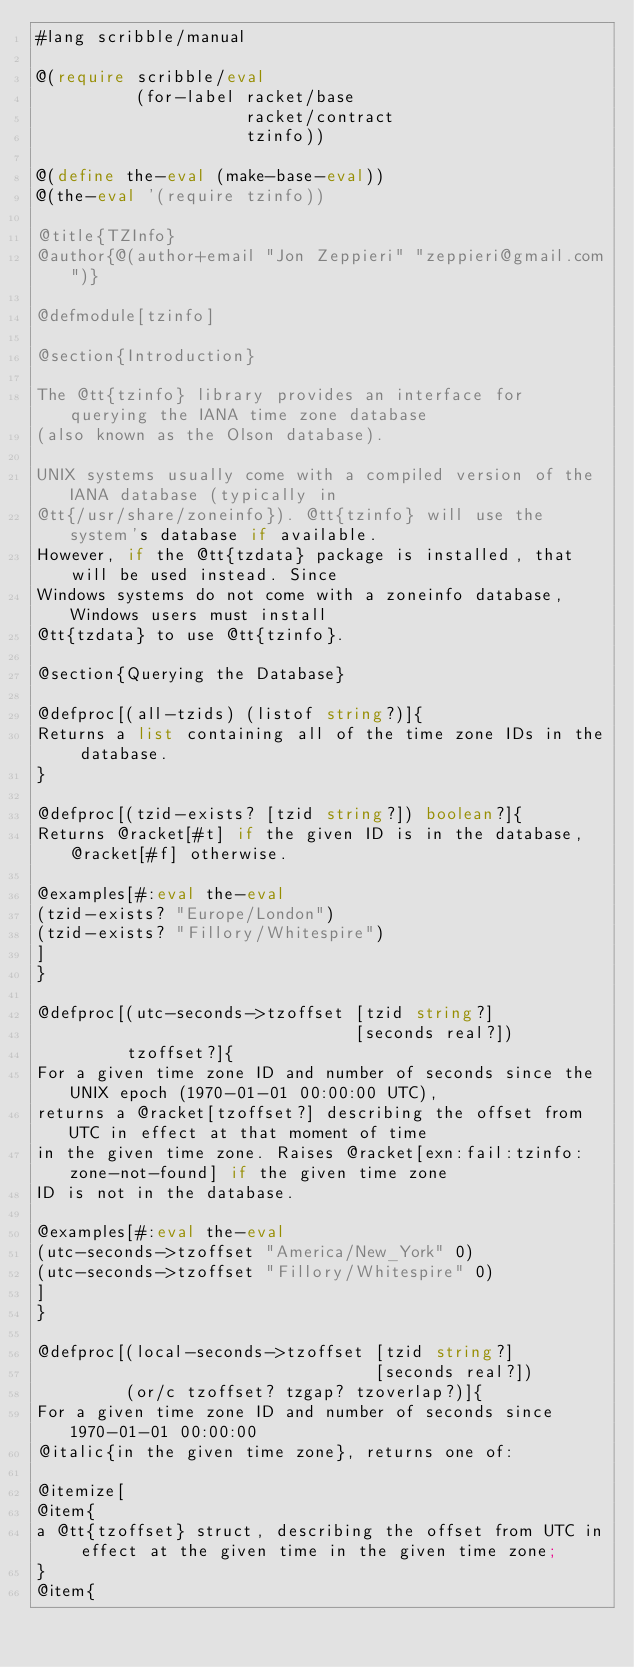<code> <loc_0><loc_0><loc_500><loc_500><_Racket_>#lang scribble/manual

@(require scribble/eval
          (for-label racket/base
                     racket/contract
                     tzinfo))

@(define the-eval (make-base-eval))
@(the-eval '(require tzinfo))

@title{TZInfo}
@author{@(author+email "Jon Zeppieri" "zeppieri@gmail.com")}

@defmodule[tzinfo]

@section{Introduction}

The @tt{tzinfo} library provides an interface for querying the IANA time zone database
(also known as the Olson database).

UNIX systems usually come with a compiled version of the IANA database (typically in
@tt{/usr/share/zoneinfo}). @tt{tzinfo} will use the system's database if available.
However, if the @tt{tzdata} package is installed, that will be used instead. Since
Windows systems do not come with a zoneinfo database, Windows users must install
@tt{tzdata} to use @tt{tzinfo}.

@section{Querying the Database}

@defproc[(all-tzids) (listof string?)]{
Returns a list containing all of the time zone IDs in the database.
}

@defproc[(tzid-exists? [tzid string?]) boolean?]{
Returns @racket[#t] if the given ID is in the database, @racket[#f] otherwise.
        
@examples[#:eval the-eval
(tzid-exists? "Europe/London")
(tzid-exists? "Fillory/Whitespire")
]
}

@defproc[(utc-seconds->tzoffset [tzid string?]
                                [seconds real?])
         tzoffset?]{
For a given time zone ID and number of seconds since the UNIX epoch (1970-01-01 00:00:00 UTC),
returns a @racket[tzoffset?] describing the offset from UTC in effect at that moment of time
in the given time zone. Raises @racket[exn:fail:tzinfo:zone-not-found] if the given time zone
ID is not in the database.

@examples[#:eval the-eval
(utc-seconds->tzoffset "America/New_York" 0)
(utc-seconds->tzoffset "Fillory/Whitespire" 0)
]
}

@defproc[(local-seconds->tzoffset [tzid string?]
                                  [seconds real?])
         (or/c tzoffset? tzgap? tzoverlap?)]{
For a given time zone ID and number of seconds since 1970-01-01 00:00:00
@italic{in the given time zone}, returns one of:

@itemize[
@item{
a @tt{tzoffset} struct, describing the offset from UTC in effect at the given time in the given time zone;
}
@item{</code> 